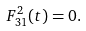<formula> <loc_0><loc_0><loc_500><loc_500>F _ { 3 1 } ^ { 2 } ( t ) = 0 .</formula> 